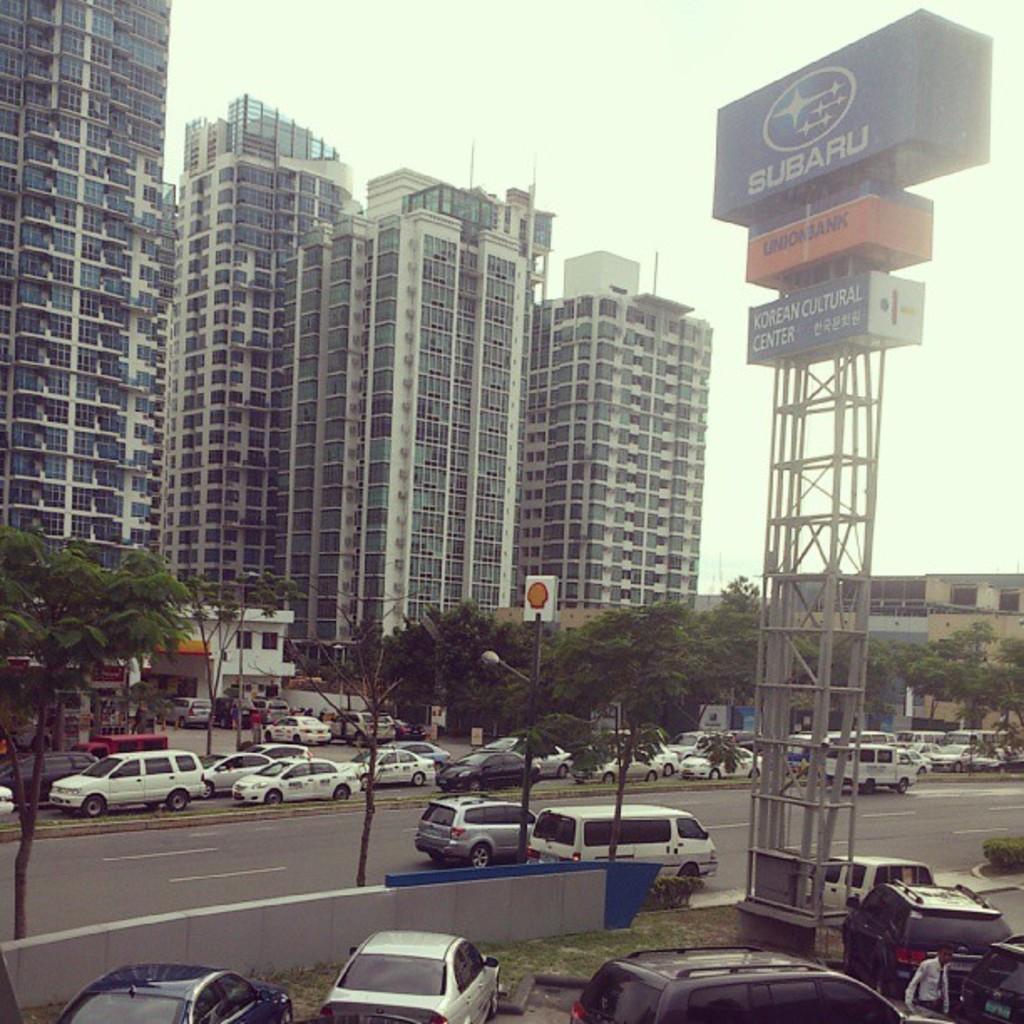How would you summarize this image in a sentence or two? In this picture I can see buildings, trees and few cars on the road and I can see few cars parked and I can see boards with some text and I can see sky. 